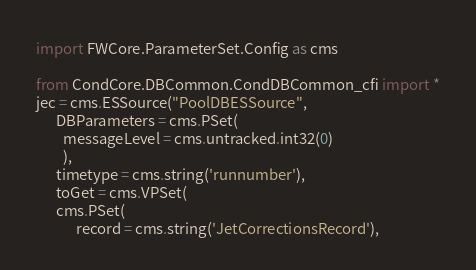Convert code to text. <code><loc_0><loc_0><loc_500><loc_500><_Python_>import FWCore.ParameterSet.Config as cms

from CondCore.DBCommon.CondDBCommon_cfi import *
jec = cms.ESSource("PoolDBESSource",
      DBParameters = cms.PSet(
        messageLevel = cms.untracked.int32(0)
        ),
      timetype = cms.string('runnumber'),
      toGet = cms.VPSet(
      cms.PSet(
            record = cms.string('JetCorrectionsRecord'),</code> 